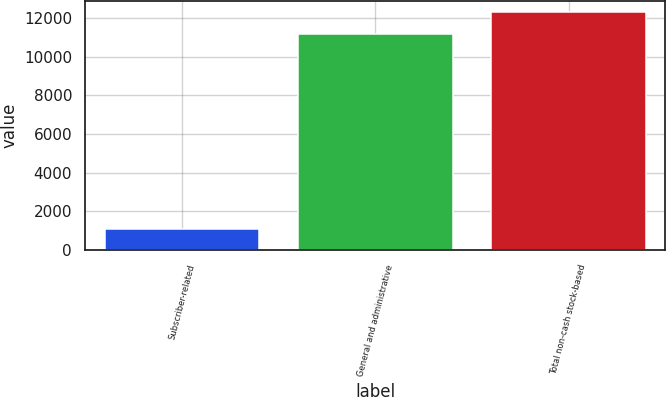<chart> <loc_0><loc_0><loc_500><loc_500><bar_chart><fcel>Subscriber-related<fcel>General and administrative<fcel>Total non-cash stock-based<nl><fcel>1069<fcel>11158<fcel>12273.8<nl></chart> 